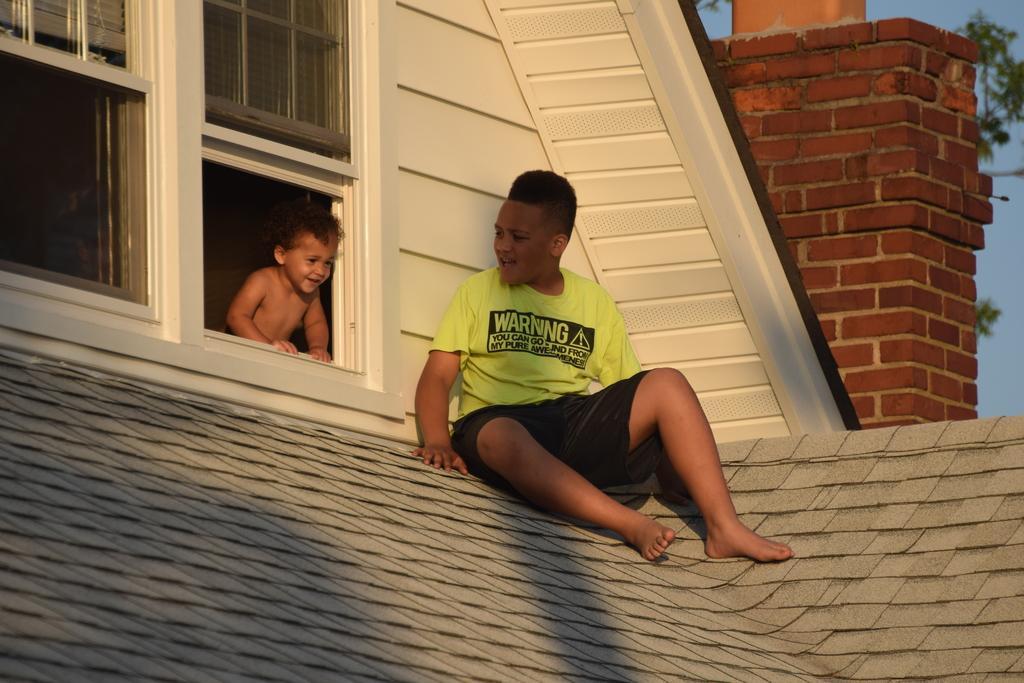Describe this image in one or two sentences. On the right side, there is a boy in yellow color t-shirt, sitting on a roof of a building. On the left side, there is a baby smiling and placing both hands on a wall of a building. In the background, there is a brick wall, a tree and sky. 